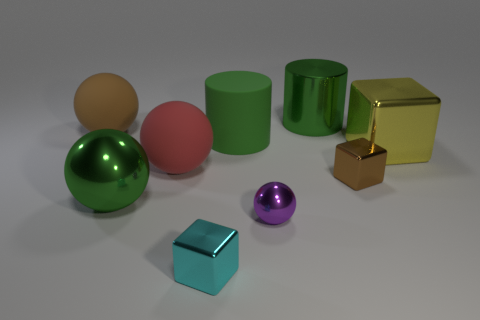Subtract all green metallic balls. How many balls are left? 3 Subtract all red spheres. How many spheres are left? 3 Subtract 1 balls. How many balls are left? 3 Add 1 tiny cylinders. How many objects exist? 10 Subtract all cubes. How many objects are left? 6 Subtract all yellow balls. Subtract all green cylinders. How many balls are left? 4 Add 7 brown matte spheres. How many brown matte spheres are left? 8 Add 7 large brown matte spheres. How many large brown matte spheres exist? 8 Subtract 0 cyan cylinders. How many objects are left? 9 Subtract all tiny brown blocks. Subtract all green metal cylinders. How many objects are left? 7 